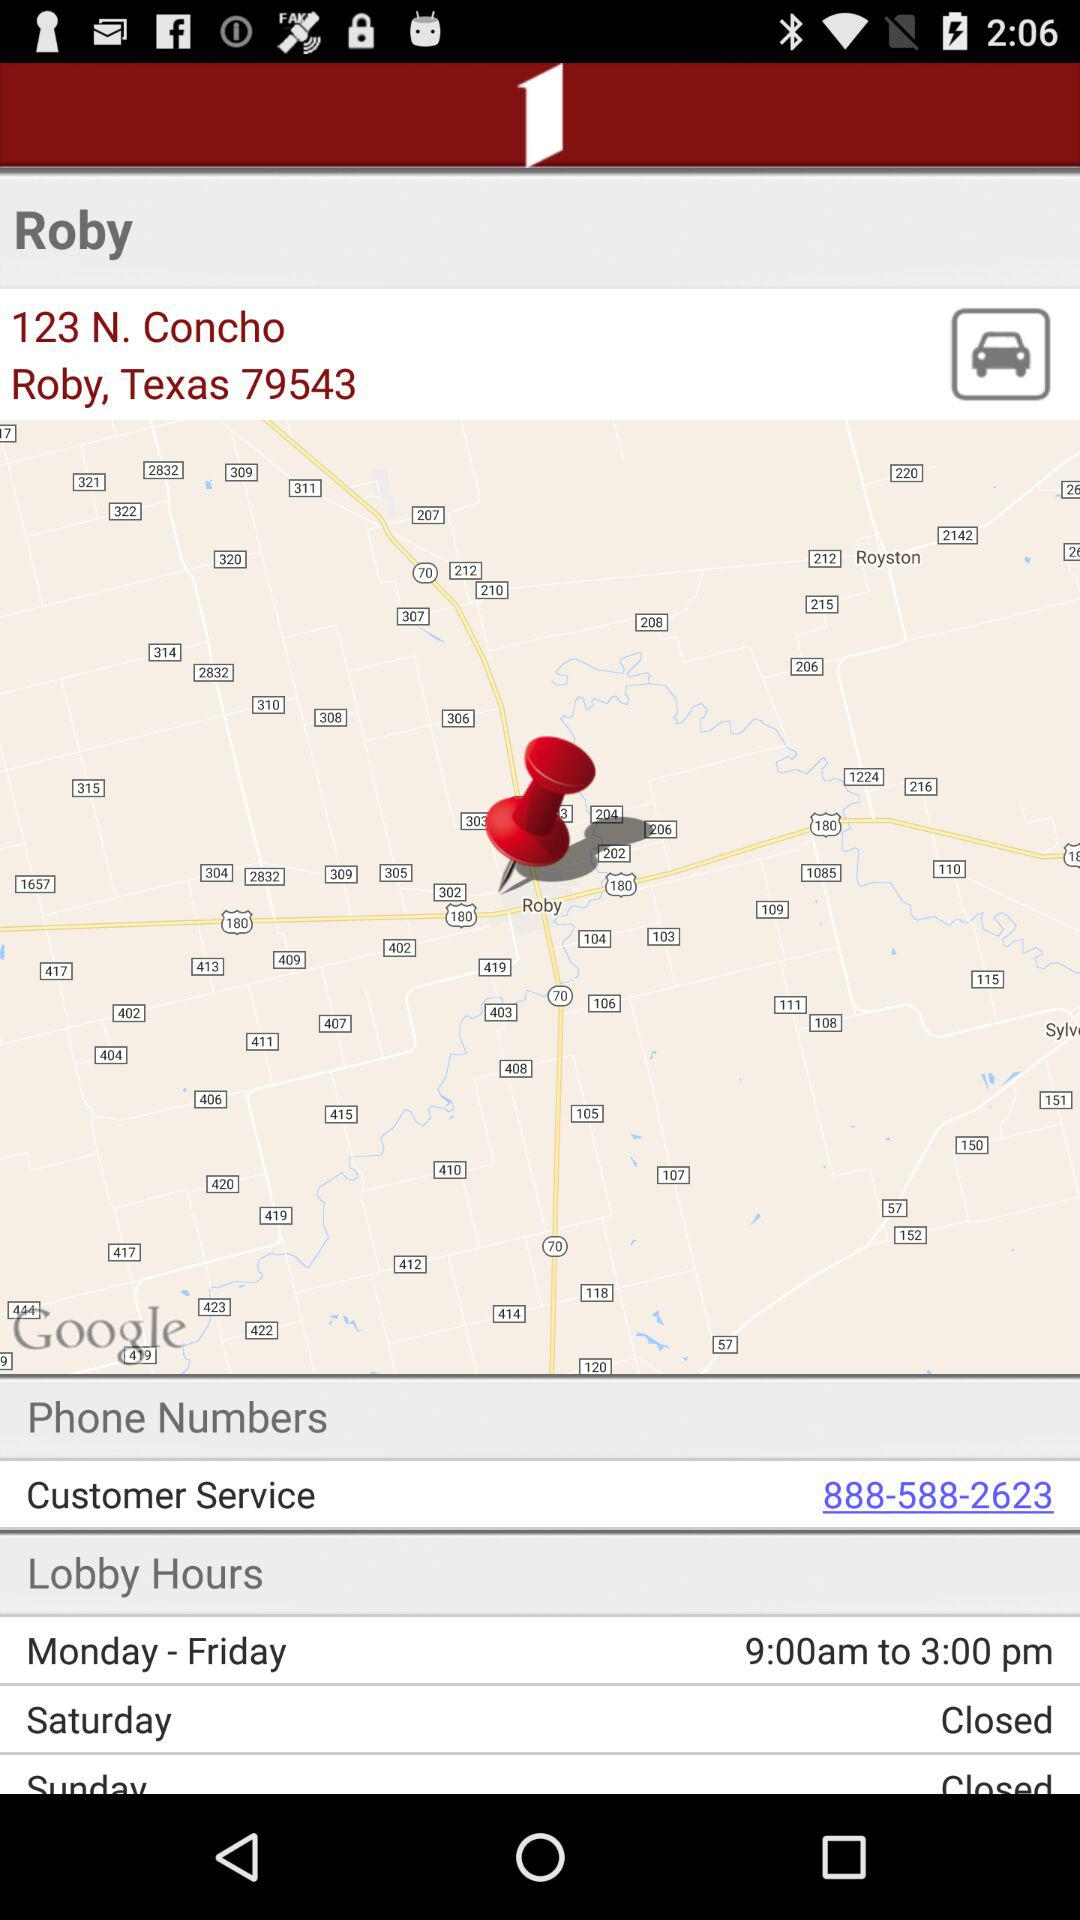What is the application name? The application name is "First Financial Mobile Banking". 